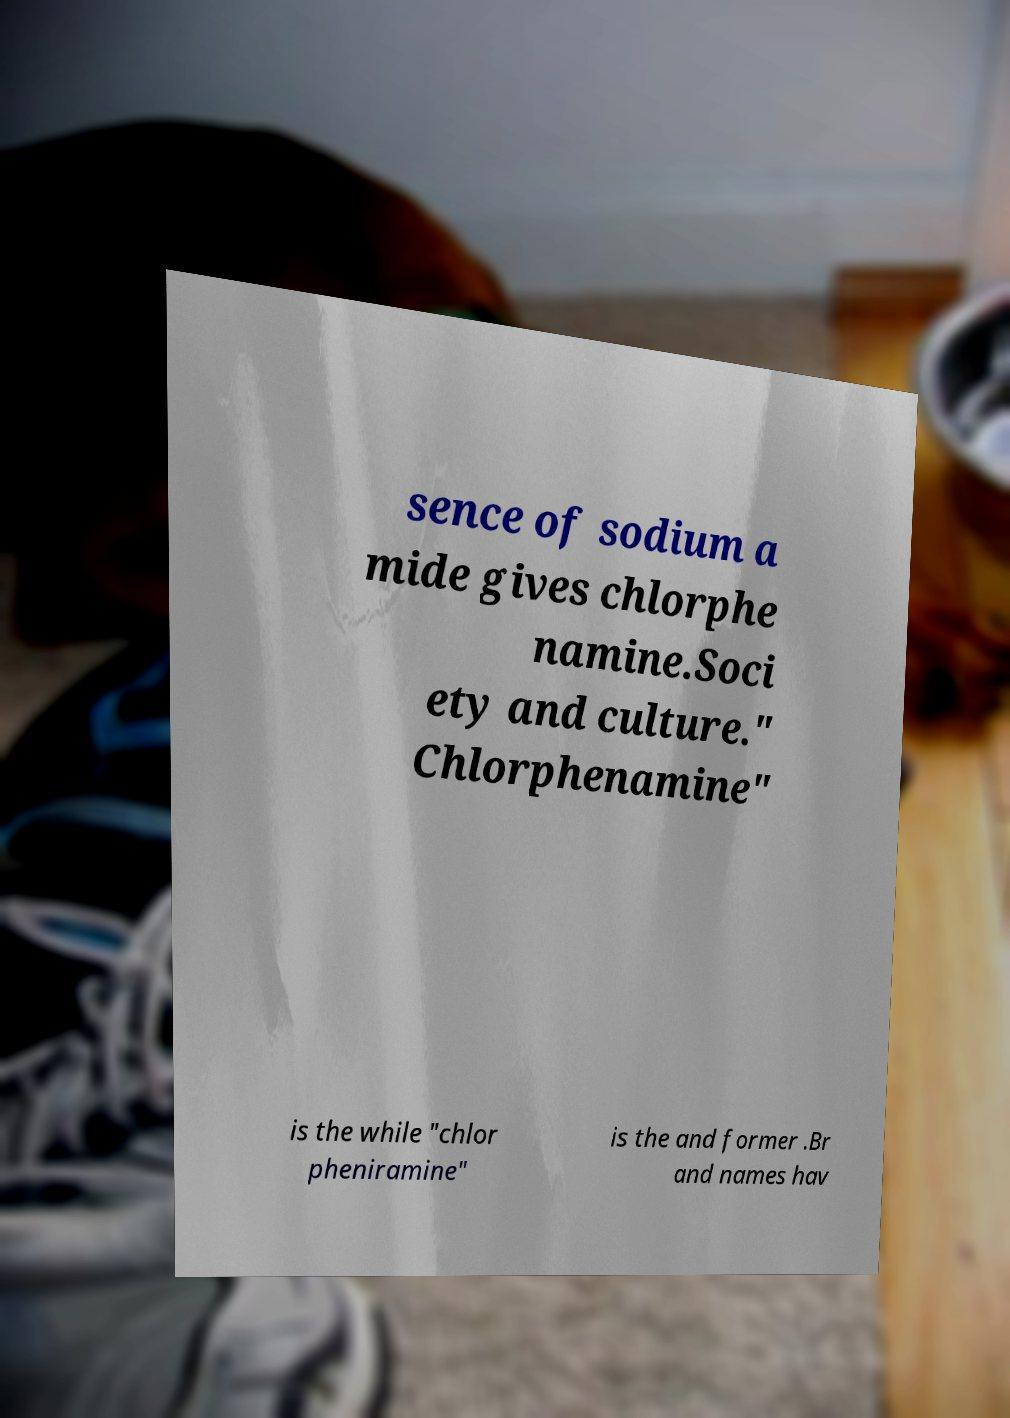Could you assist in decoding the text presented in this image and type it out clearly? sence of sodium a mide gives chlorphe namine.Soci ety and culture." Chlorphenamine" is the while "chlor pheniramine" is the and former .Br and names hav 